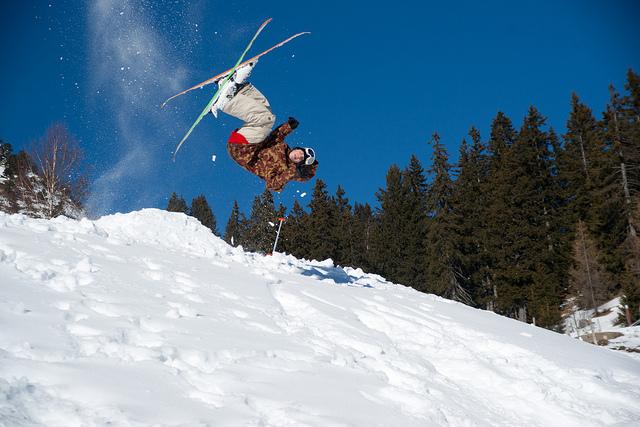Where are the trees' shadows?
Write a very short answer. Behind them. Is this person attempting a stunt or are they falling?
Keep it brief. Stunt. What sport is the man doing?
Concise answer only. Skiing. What is the person doing?
Concise answer only. Skiing. Is the man falling?
Give a very brief answer. Yes. Why are her skis crossed?
Write a very short answer. Trick. What is the person doing in this picture?
Quick response, please. Skiing. What is the person wearing on their feet?
Answer briefly. Skis. What color is his coat?
Quick response, please. Brown. Is the tree without leaves dead?
Concise answer only. No. What is showing in the background?
Write a very short answer. Trees. 